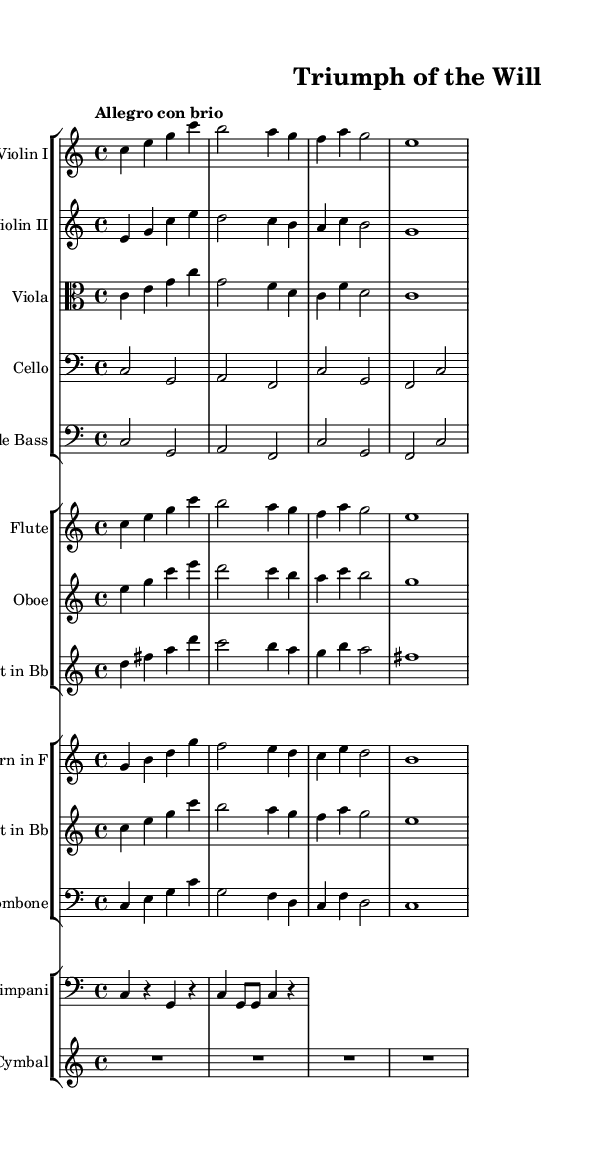What is the key signature of this music? The key signature is found at the beginning of the piece. Here, it shows that there are no sharps or flats, indicating it's in C major.
Answer: C major What is the time signature of this music? The time signature is located at the beginning of the piece next to the key signature. It reads 4/4, meaning there are four beats in each measure and quarter note receives one beat.
Answer: 4/4 What is the tempo marking for this piece? The tempo marking is indicated at the beginning, and it states "Allegro con brio," which typically means to play in a lively manner.
Answer: Allegro con brio Which instruments are featured in this orchestral composition? The sheet music lists various instruments in groups. Notably included are Violin I, Violin II, Viola, Cello, Double Bass, Flute, Oboe, Clarinet, Horn, Trumpet, Trombone, Timpani, and Crash Cymbal.
Answer: Multiple instruments How many measures are there in the main theme for the strings? The main themes for the strings (Violin I, Violin II, Viola, Cello, Double Bass) consist of 4 measures, as observed in the first group of notes for each string instrument.
Answer: 4 measures What is the role of the timpani in this orchestral composition? The timpani often serves a rhythmic and dramatic purpose in orchestral music. Here, it adds punctuation; the part includes notes spaced for emphasis, contributing to the uplifting energy of the piece.
Answer: Rhythmic punctuation 